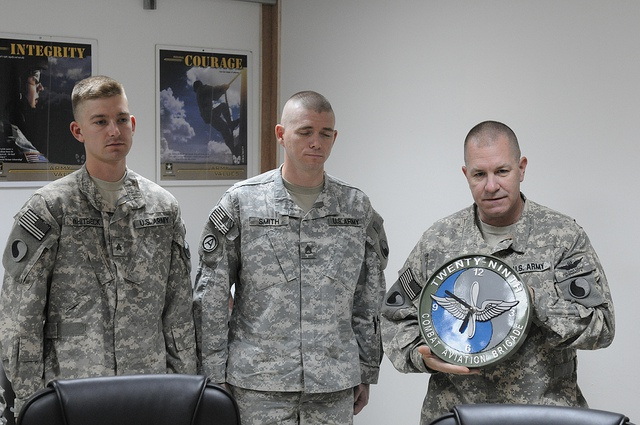Describe the objects in this image and their specific colors. I can see people in gray, darkgray, black, and lightgray tones, people in gray, darkgray, black, and lightgray tones, people in gray, black, and darkgray tones, clock in gray, darkgray, lightgray, and black tones, and chair in gray and black tones in this image. 